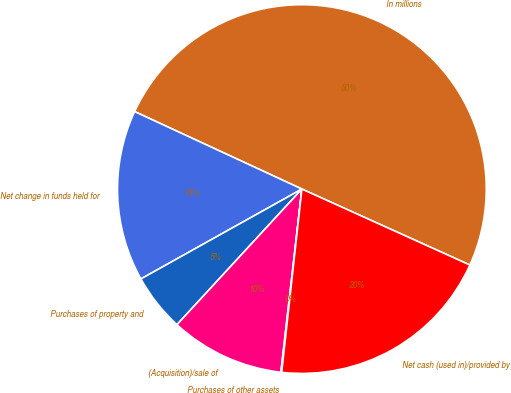<chart> <loc_0><loc_0><loc_500><loc_500><pie_chart><fcel>In millions<fcel>Net change in funds held for<fcel>Purchases of property and<fcel>(Acquisition)/sale of<fcel>Purchases of other assets<fcel>Net cash (used in)/provided by<nl><fcel>49.86%<fcel>15.01%<fcel>5.05%<fcel>10.03%<fcel>0.07%<fcel>19.99%<nl></chart> 